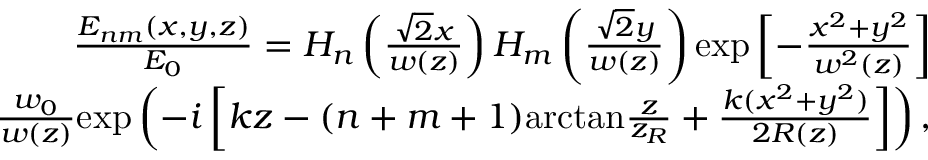Convert formula to latex. <formula><loc_0><loc_0><loc_500><loc_500>\begin{array} { r } { \frac { E _ { n m } ( x , y , z ) } { E _ { 0 } } = H _ { n } \left ( \frac { \sqrt { 2 } x } { w ( z ) } \right ) H _ { m } \left ( \frac { \sqrt { 2 } y } { w ( z ) } \right ) e x p \left [ - \frac { x ^ { 2 } + y ^ { 2 } } { w ^ { 2 } ( z ) } \right ] } \\ { \frac { w _ { 0 } } { w ( z ) } e x p \left ( - i \left [ k z - ( n + m + 1 ) a r c t a n \frac { z } { z _ { R } } + \frac { k ( x ^ { 2 } + y ^ { 2 } ) } { 2 R ( z ) } \right ] \right ) , } \end{array}</formula> 